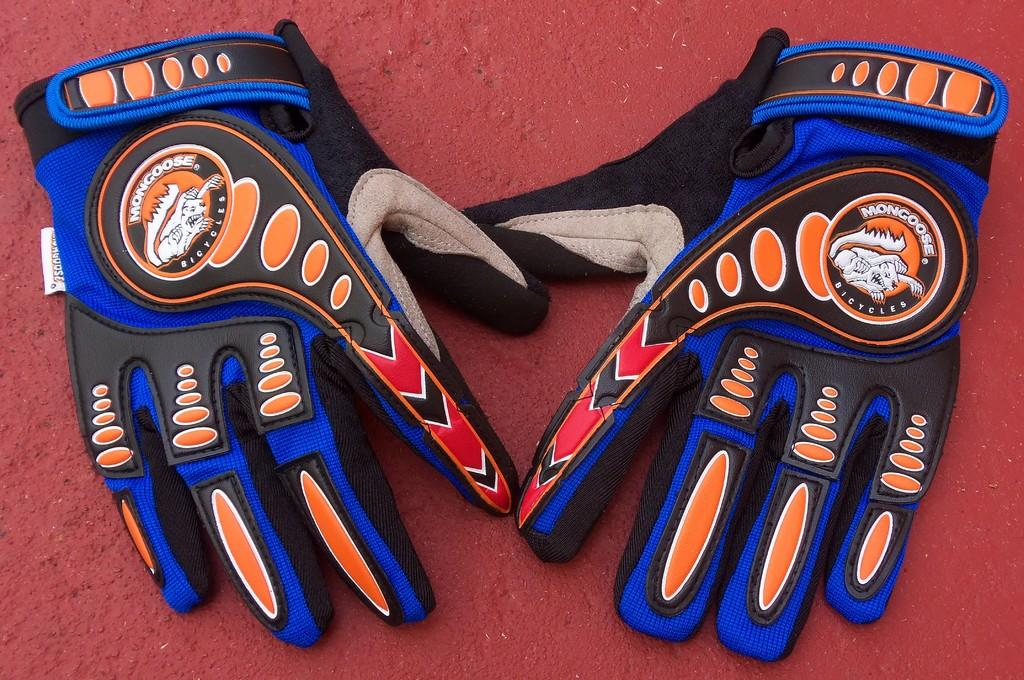What type of clothing item is present in the image? There is a pair of gloves in the image. What colors can be seen on the gloves? The gloves have blue, black, red, and orange colors. On what surface are the gloves placed? The gloves are placed on a red surface. How does your mom feel about the gloves in the image? The image does not provide any information about your mom's feelings or opinions about the gloves. 